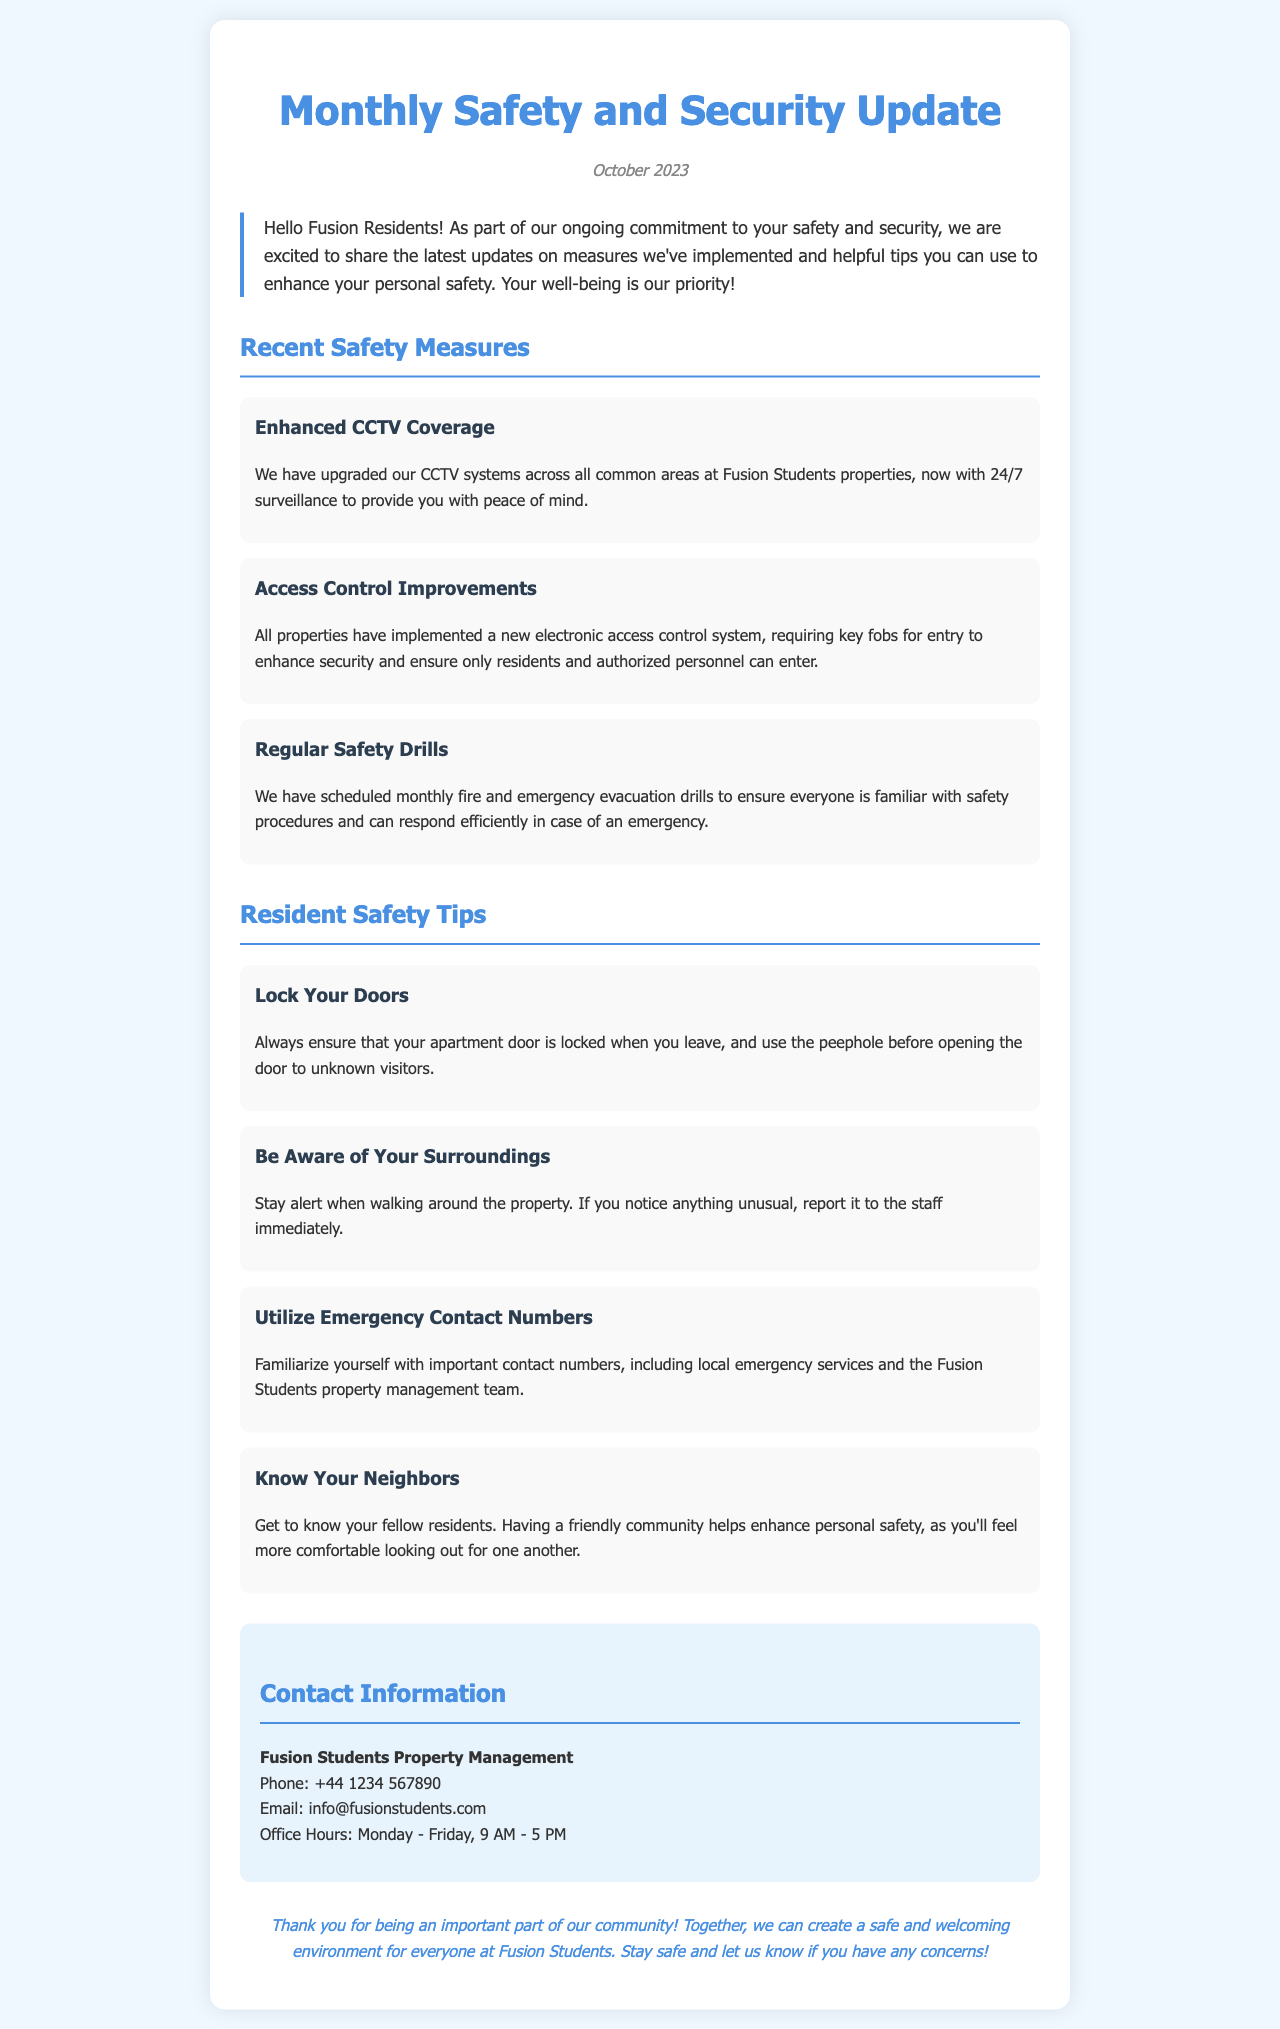What is the title of the newsletter? The title of the newsletter is stated at the beginning of the document.
Answer: Monthly Safety and Security Update What new system has been implemented for property access? The document specifies a new feature designed to increase security for residents.
Answer: electronic access control system How many fire and emergency drills are scheduled each month? The document mentions a specific frequency for safety drills.
Answer: monthly What is one of the safety tips mentioned in the newsletter? The newsletter contains a list of tips aimed at enhancing personal safety.
Answer: Lock Your Doors What is the contact phone number for Fusion Students Property Management? The contact information section provides a specific phone number for residents to reach property management.
Answer: +44 1234 567890 How does the newsletter suggest getting to know your neighbors impacts safety? The newsletter implies a connection between community relationships and personal safety.
Answer: enhances personal safety What color is used for the main headings in the document? The color of the headings is a detail that contributes to the visual style of the document.
Answer: #4a90e2 What is the stated office hour range for property management? The office hours are specified to inform residents when they can contact management.
Answer: 9 AM - 5 PM 